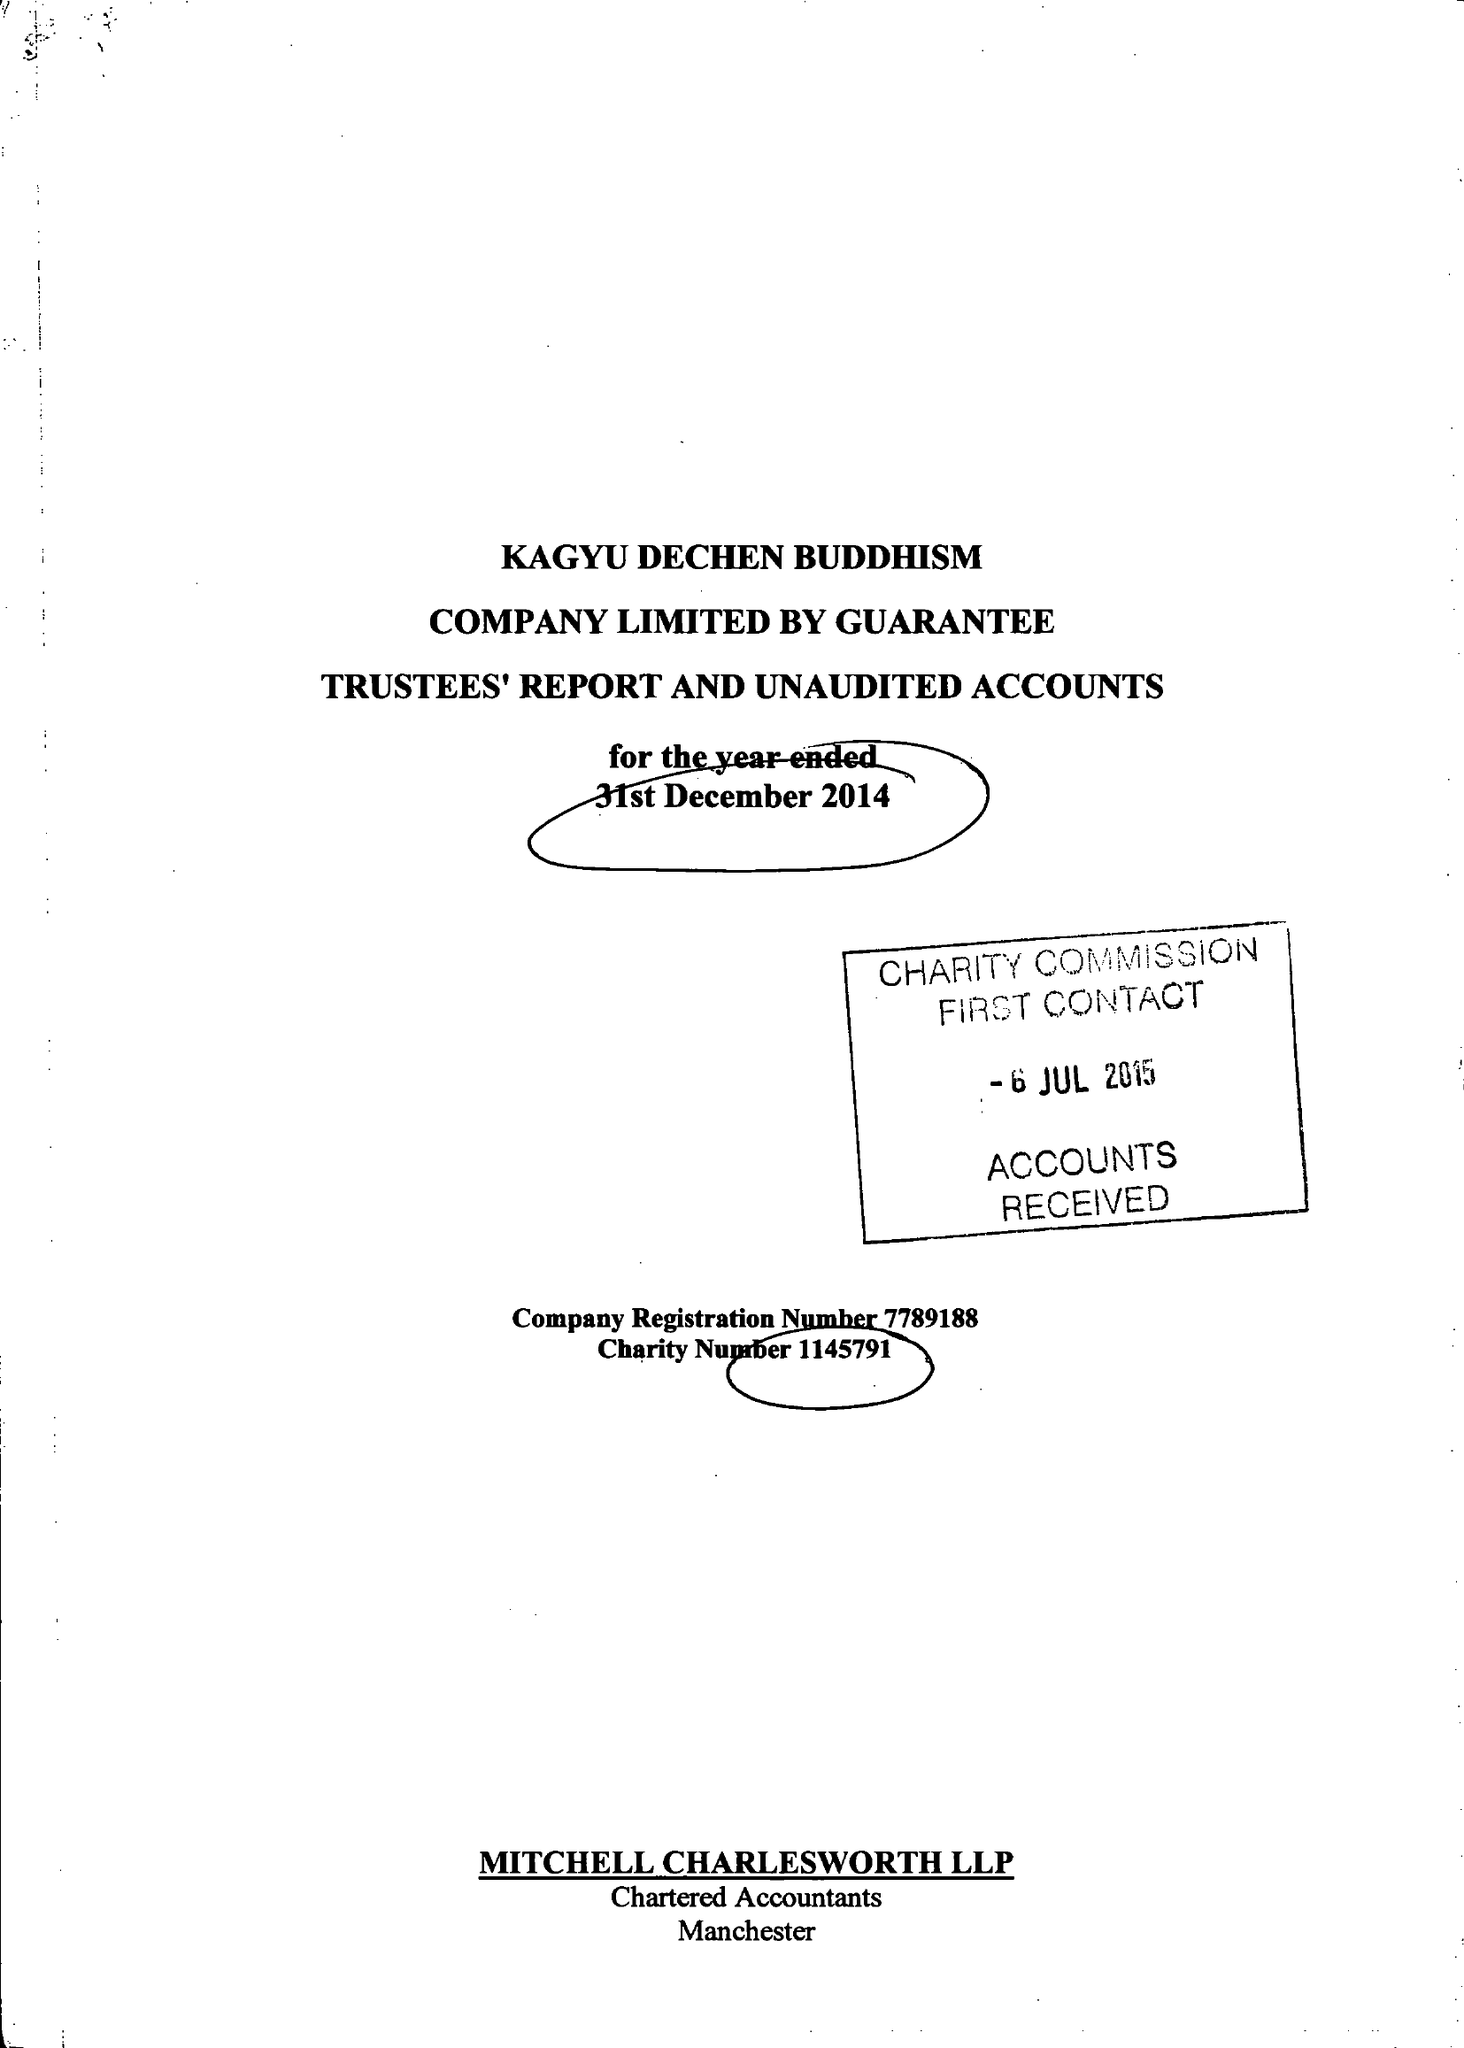What is the value for the address__postcode?
Answer the question using a single word or phrase. M21 7QG 